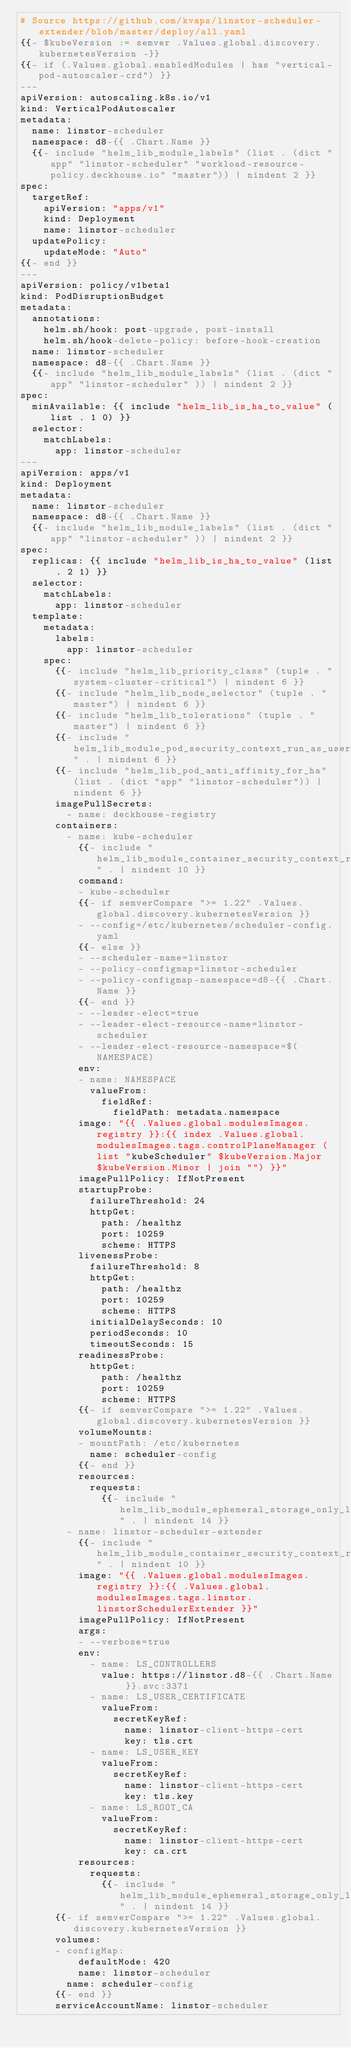Convert code to text. <code><loc_0><loc_0><loc_500><loc_500><_YAML_># Source https://github.com/kvaps/linstor-scheduler-extender/blob/master/deploy/all.yaml
{{- $kubeVersion := semver .Values.global.discovery.kubernetesVersion -}}
{{- if (.Values.global.enabledModules | has "vertical-pod-autoscaler-crd") }}
---
apiVersion: autoscaling.k8s.io/v1
kind: VerticalPodAutoscaler
metadata:
  name: linstor-scheduler
  namespace: d8-{{ .Chart.Name }}
  {{- include "helm_lib_module_labels" (list . (dict "app" "linstor-scheduler" "workload-resource-policy.deckhouse.io" "master")) | nindent 2 }}
spec:
  targetRef:
    apiVersion: "apps/v1"
    kind: Deployment
    name: linstor-scheduler
  updatePolicy:
    updateMode: "Auto"
{{- end }}
---
apiVersion: policy/v1beta1
kind: PodDisruptionBudget
metadata:
  annotations:
    helm.sh/hook: post-upgrade, post-install
    helm.sh/hook-delete-policy: before-hook-creation
  name: linstor-scheduler
  namespace: d8-{{ .Chart.Name }}
  {{- include "helm_lib_module_labels" (list . (dict "app" "linstor-scheduler" )) | nindent 2 }}
spec:
  minAvailable: {{ include "helm_lib_is_ha_to_value" (list . 1 0) }}
  selector:
    matchLabels:
      app: linstor-scheduler
---
apiVersion: apps/v1
kind: Deployment
metadata:
  name: linstor-scheduler
  namespace: d8-{{ .Chart.Name }}
  {{- include "helm_lib_module_labels" (list . (dict "app" "linstor-scheduler" )) | nindent 2 }}
spec:
  replicas: {{ include "helm_lib_is_ha_to_value" (list . 2 1) }}
  selector:
    matchLabels:
      app: linstor-scheduler
  template:
    metadata:
      labels:
        app: linstor-scheduler
    spec:
      {{- include "helm_lib_priority_class" (tuple . "system-cluster-critical") | nindent 6 }}
      {{- include "helm_lib_node_selector" (tuple . "master") | nindent 6 }}
      {{- include "helm_lib_tolerations" (tuple . "master") | nindent 6 }}
      {{- include "helm_lib_module_pod_security_context_run_as_user_nobody" . | nindent 6 }}
      {{- include "helm_lib_pod_anti_affinity_for_ha" (list . (dict "app" "linstor-scheduler")) | nindent 6 }}
      imagePullSecrets:
        - name: deckhouse-registry
      containers:
        - name: kube-scheduler
          {{- include "helm_lib_module_container_security_context_read_only_root_filesystem_capabilities_drop_all" . | nindent 10 }}
          command:
          - kube-scheduler
          {{- if semverCompare ">= 1.22" .Values.global.discovery.kubernetesVersion }}
          - --config=/etc/kubernetes/scheduler-config.yaml
          {{- else }}
          - --scheduler-name=linstor
          - --policy-configmap=linstor-scheduler
          - --policy-configmap-namespace=d8-{{ .Chart.Name }}
          {{- end }}
          - --leader-elect=true
          - --leader-elect-resource-name=linstor-scheduler
          - --leader-elect-resource-namespace=$(NAMESPACE)
          env:
          - name: NAMESPACE
            valueFrom:
              fieldRef:
                fieldPath: metadata.namespace
          image: "{{ .Values.global.modulesImages.registry }}:{{ index .Values.global.modulesImages.tags.controlPlaneManager (list "kubeScheduler" $kubeVersion.Major $kubeVersion.Minor | join "") }}"
          imagePullPolicy: IfNotPresent
          startupProbe:
            failureThreshold: 24
            httpGet:
              path: /healthz
              port: 10259
              scheme: HTTPS
          livenessProbe:
            failureThreshold: 8
            httpGet:
              path: /healthz
              port: 10259
              scheme: HTTPS
            initialDelaySeconds: 10
            periodSeconds: 10
            timeoutSeconds: 15
          readinessProbe:
            httpGet:
              path: /healthz
              port: 10259
              scheme: HTTPS
          {{- if semverCompare ">= 1.22" .Values.global.discovery.kubernetesVersion }}
          volumeMounts:
          - mountPath: /etc/kubernetes
            name: scheduler-config
          {{- end }}
          resources:
            requests:
              {{- include "helm_lib_module_ephemeral_storage_only_logs" . | nindent 14 }}
        - name: linstor-scheduler-extender
          {{- include "helm_lib_module_container_security_context_read_only_root_filesystem_capabilities_drop_all" . | nindent 10 }}
          image: "{{ .Values.global.modulesImages.registry }}:{{ .Values.global.modulesImages.tags.linstor.linstorSchedulerExtender }}"
          imagePullPolicy: IfNotPresent
          args:
          - --verbose=true
          env:
            - name: LS_CONTROLLERS
              value: https://linstor.d8-{{ .Chart.Name }}.svc:3371
            - name: LS_USER_CERTIFICATE
              valueFrom:
                secretKeyRef:
                  name: linstor-client-https-cert
                  key: tls.crt
            - name: LS_USER_KEY
              valueFrom:
                secretKeyRef:
                  name: linstor-client-https-cert
                  key: tls.key
            - name: LS_ROOT_CA
              valueFrom:
                secretKeyRef:
                  name: linstor-client-https-cert
                  key: ca.crt
          resources:
            requests:
              {{- include "helm_lib_module_ephemeral_storage_only_logs" . | nindent 14 }}
      {{- if semverCompare ">= 1.22" .Values.global.discovery.kubernetesVersion }}
      volumes:
      - configMap:
          defaultMode: 420
          name: linstor-scheduler
        name: scheduler-config
      {{- end }}
      serviceAccountName: linstor-scheduler
</code> 